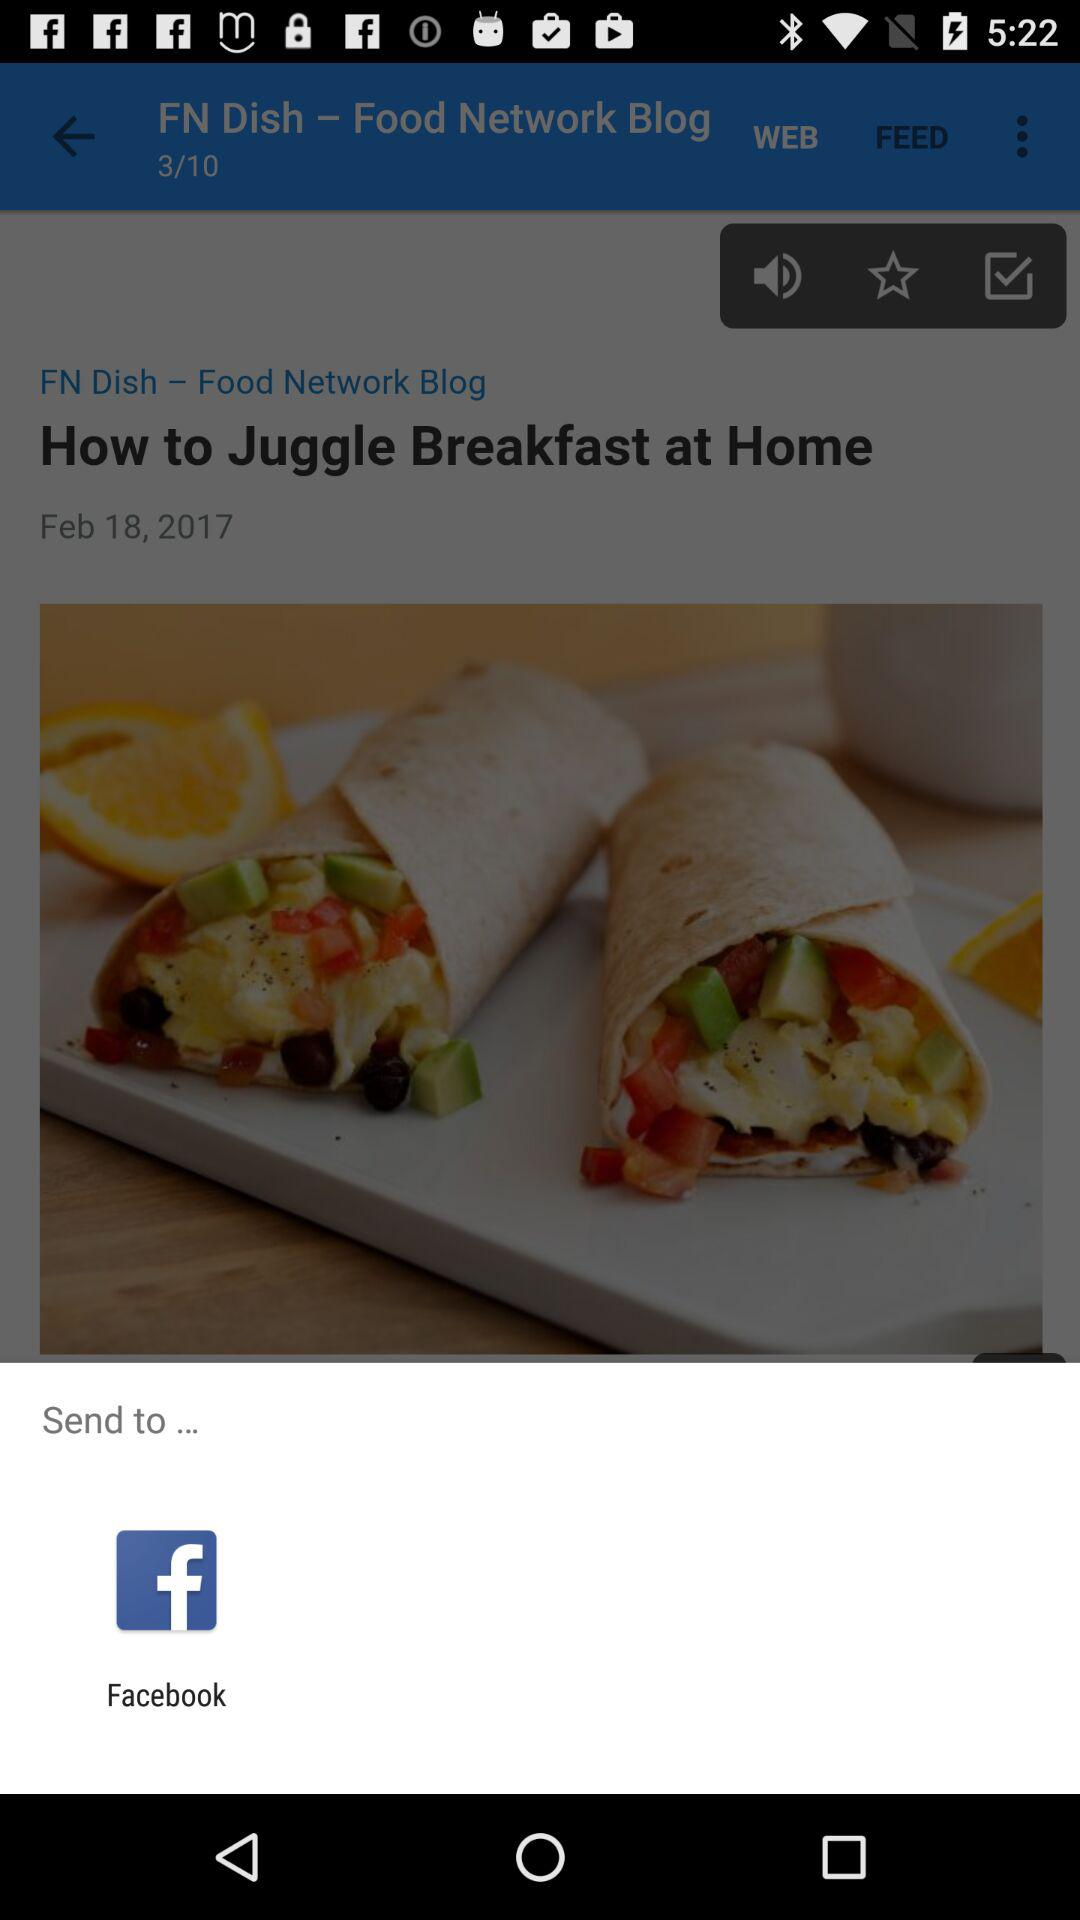What date was "How to Juggle Breakfast at Home" posted? It was posted on February 18, 2017. 